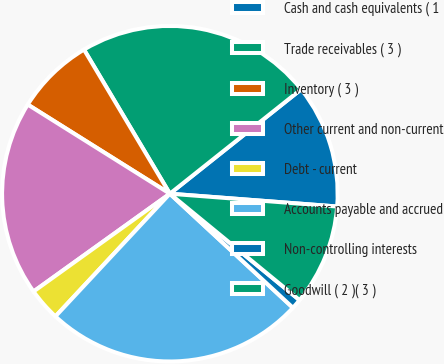Convert chart. <chart><loc_0><loc_0><loc_500><loc_500><pie_chart><fcel>Cash and cash equivalents ( 1<fcel>Trade receivables ( 3 )<fcel>Inventory ( 3 )<fcel>Other current and non-current<fcel>Debt - current<fcel>Accounts payable and accrued<fcel>Non-controlling interests<fcel>Goodwill ( 2 )( 3 )<nl><fcel>11.91%<fcel>22.86%<fcel>7.53%<fcel>18.82%<fcel>3.15%<fcel>25.05%<fcel>0.96%<fcel>9.72%<nl></chart> 